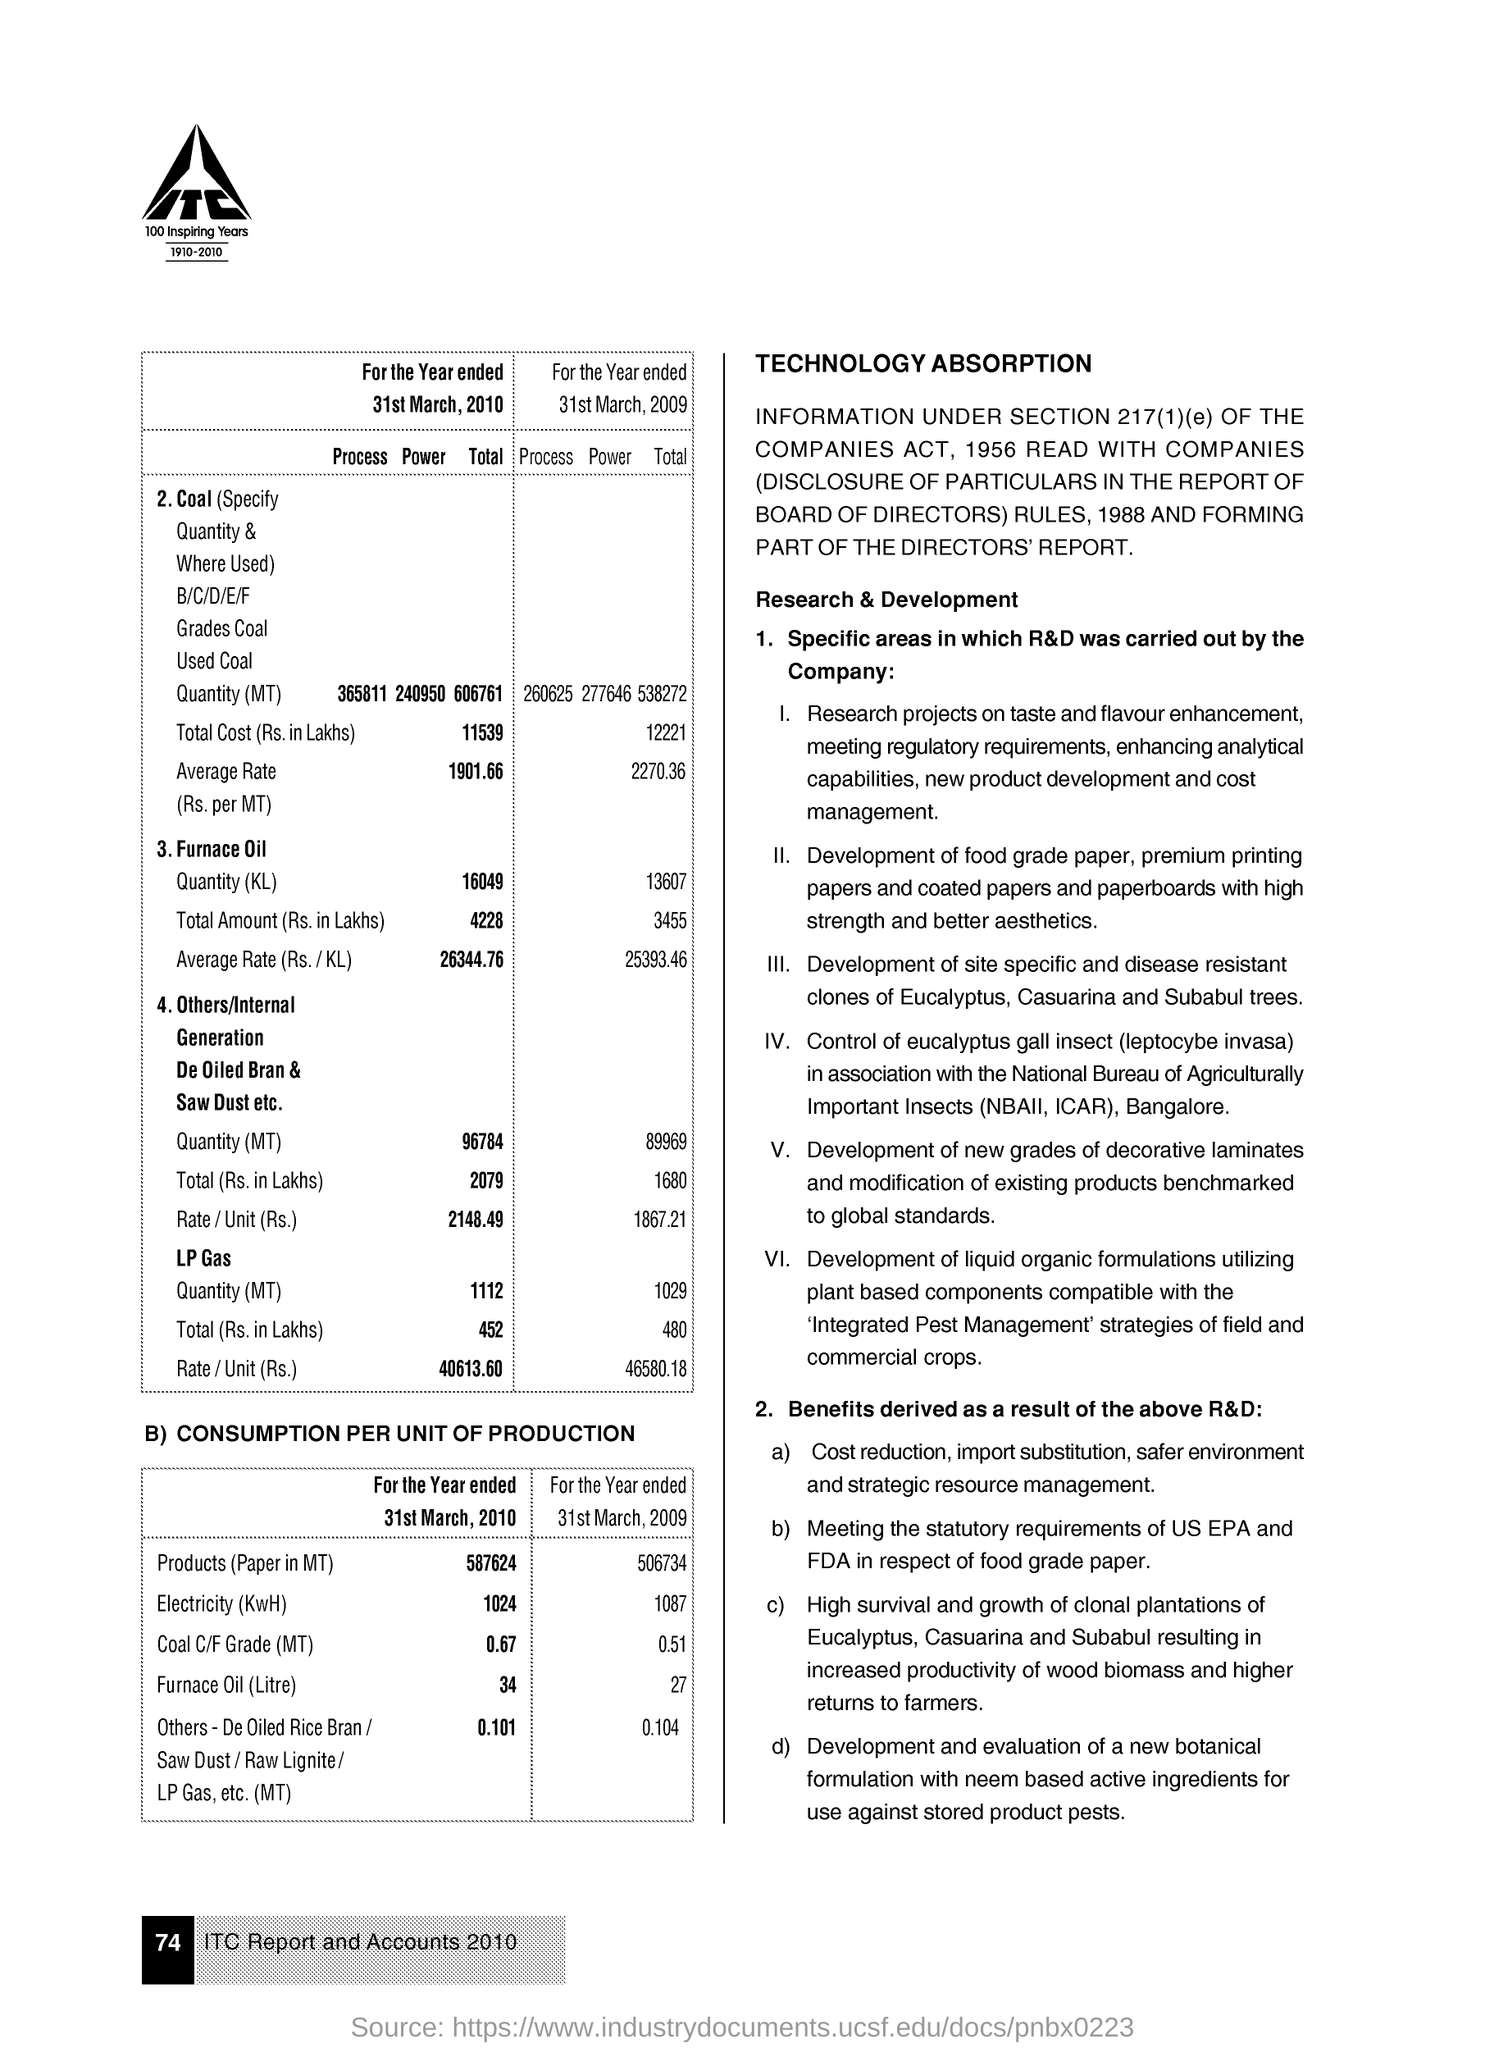Draw attention to some important aspects in this diagram. The furnace oil consumption for the year ended on March 31, 2010 was 34 liters. The electricity usage for the year ended on March 31, 2009, was 1087 kilowatt-hours. The electricity usage (in KwH) for the year ended on March 31, 2010, was 1024. The coal C/F grade (in megatons) for the year ended March 31, 2010 was 0.67. The Coal C/F Grade (Metric Tons) for the year ended 31st March, 2009 was 0.51. 